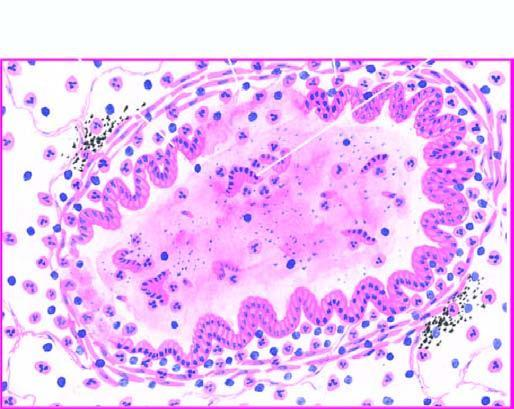s the mucosa sloughed off at places with exudate of muco-pus in the lumen?
Answer the question using a single word or phrase. Yes 